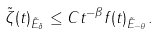<formula> <loc_0><loc_0><loc_500><loc_500>\| \tilde { \zeta } ( t ) \| _ { \tilde { E } _ { \delta } } \leq C t ^ { - \beta } \| f ( t ) \| _ { \tilde { E } _ { - \theta } } .</formula> 